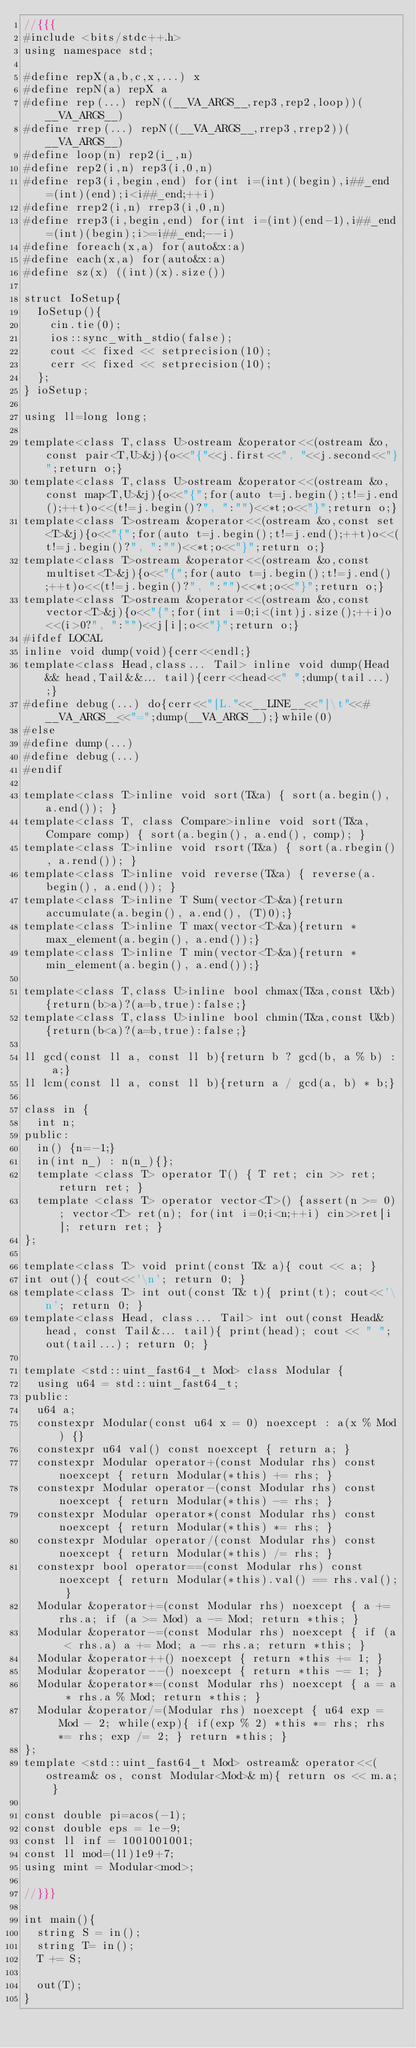<code> <loc_0><loc_0><loc_500><loc_500><_C++_>//{{{
#include <bits/stdc++.h>
using namespace std;

#define repX(a,b,c,x,...) x
#define repN(a) repX a
#define rep(...) repN((__VA_ARGS__,rep3,rep2,loop))(__VA_ARGS__)
#define rrep(...) repN((__VA_ARGS__,rrep3,rrep2))(__VA_ARGS__)
#define loop(n) rep2(i_,n)
#define rep2(i,n) rep3(i,0,n)
#define rep3(i,begin,end) for(int i=(int)(begin),i##_end=(int)(end);i<i##_end;++i)
#define rrep2(i,n) rrep3(i,0,n)
#define rrep3(i,begin,end) for(int i=(int)(end-1),i##_end=(int)(begin);i>=i##_end;--i)
#define foreach(x,a) for(auto&x:a)
#define each(x,a) for(auto&x:a)
#define sz(x) ((int)(x).size())

struct IoSetup{
  IoSetup(){
    cin.tie(0);
    ios::sync_with_stdio(false);
    cout << fixed << setprecision(10);
    cerr << fixed << setprecision(10);
  };
} ioSetup;

using ll=long long;

template<class T,class U>ostream &operator<<(ostream &o,const pair<T,U>&j){o<<"{"<<j.first<<", "<<j.second<<"}";return o;}
template<class T,class U>ostream &operator<<(ostream &o,const map<T,U>&j){o<<"{";for(auto t=j.begin();t!=j.end();++t)o<<(t!=j.begin()?", ":"")<<*t;o<<"}";return o;}
template<class T>ostream &operator<<(ostream &o,const set<T>&j){o<<"{";for(auto t=j.begin();t!=j.end();++t)o<<(t!=j.begin()?", ":"")<<*t;o<<"}";return o;}
template<class T>ostream &operator<<(ostream &o,const multiset<T>&j){o<<"{";for(auto t=j.begin();t!=j.end();++t)o<<(t!=j.begin()?", ":"")<<*t;o<<"}";return o;}
template<class T>ostream &operator<<(ostream &o,const vector<T>&j){o<<"{";for(int i=0;i<(int)j.size();++i)o<<(i>0?", ":"")<<j[i];o<<"}";return o;}
#ifdef LOCAL
inline void dump(void){cerr<<endl;}
template<class Head,class... Tail> inline void dump(Head&& head,Tail&&... tail){cerr<<head<<" ";dump(tail...);}
#define debug(...) do{cerr<<"[L."<<__LINE__<<"]\t"<<#__VA_ARGS__<<"=";dump(__VA_ARGS__);}while(0)
#else
#define dump(...)
#define debug(...)
#endif

template<class T>inline void sort(T&a) { sort(a.begin(), a.end()); }
template<class T, class Compare>inline void sort(T&a, Compare comp) { sort(a.begin(), a.end(), comp); }
template<class T>inline void rsort(T&a) { sort(a.rbegin(), a.rend()); }
template<class T>inline void reverse(T&a) { reverse(a.begin(), a.end()); }
template<class T>inline T Sum(vector<T>&a){return accumulate(a.begin(), a.end(), (T)0);}
template<class T>inline T max(vector<T>&a){return *max_element(a.begin(), a.end());}
template<class T>inline T min(vector<T>&a){return *min_element(a.begin(), a.end());}

template<class T,class U>inline bool chmax(T&a,const U&b){return(b>a)?(a=b,true):false;}
template<class T,class U>inline bool chmin(T&a,const U&b){return(b<a)?(a=b,true):false;}

ll gcd(const ll a, const ll b){return b ? gcd(b, a % b) : a;}
ll lcm(const ll a, const ll b){return a / gcd(a, b) * b;}

class in {
  int n;
public:
  in() {n=-1;}
  in(int n_) : n(n_){};
  template <class T> operator T() { T ret; cin >> ret; return ret; }
  template <class T> operator vector<T>() {assert(n >= 0); vector<T> ret(n); for(int i=0;i<n;++i) cin>>ret[i]; return ret; }
};

template<class T> void print(const T& a){ cout << a; }
int out(){ cout<<'\n'; return 0; }
template<class T> int out(const T& t){ print(t); cout<<'\n'; return 0; }
template<class Head, class... Tail> int out(const Head& head, const Tail&... tail){ print(head); cout << " "; out(tail...); return 0; }

template <std::uint_fast64_t Mod> class Modular {
  using u64 = std::uint_fast64_t;
public:
  u64 a;
  constexpr Modular(const u64 x = 0) noexcept : a(x % Mod) {}
  constexpr u64 val() const noexcept { return a; }
  constexpr Modular operator+(const Modular rhs) const noexcept { return Modular(*this) += rhs; }
  constexpr Modular operator-(const Modular rhs) const noexcept { return Modular(*this) -= rhs; }
  constexpr Modular operator*(const Modular rhs) const noexcept { return Modular(*this) *= rhs; }
  constexpr Modular operator/(const Modular rhs) const noexcept { return Modular(*this) /= rhs; }
  constexpr bool operator==(const Modular rhs) const noexcept { return Modular(*this).val() == rhs.val(); }
  Modular &operator+=(const Modular rhs) noexcept { a += rhs.a; if (a >= Mod) a -= Mod; return *this; }
  Modular &operator-=(const Modular rhs) noexcept { if (a < rhs.a) a += Mod; a -= rhs.a; return *this; }
  Modular &operator++() noexcept { return *this += 1; }
  Modular &operator--() noexcept { return *this -= 1; }
  Modular &operator*=(const Modular rhs) noexcept { a = a * rhs.a % Mod; return *this; }
  Modular &operator/=(Modular rhs) noexcept { u64 exp = Mod - 2; while(exp){ if(exp % 2) *this *= rhs; rhs *= rhs; exp /= 2; } return *this; }
};
template <std::uint_fast64_t Mod> ostream& operator<<(ostream& os, const Modular<Mod>& m){ return os << m.a; }

const double pi=acos(-1);
const double eps = 1e-9;
const ll inf = 1001001001;
const ll mod=(ll)1e9+7;
using mint = Modular<mod>;

//}}}

int main(){
  string S = in();
  string T= in();
  T += S;

  out(T);
}
</code> 